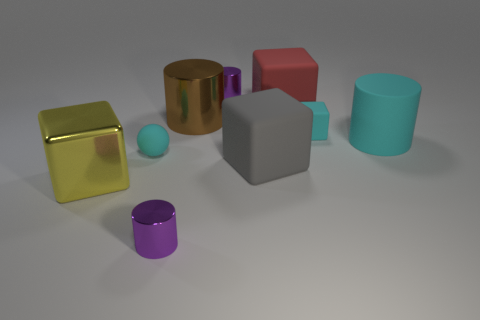Is the number of tiny cylinders in front of the brown cylinder the same as the number of gray matte cubes to the left of the yellow thing?
Keep it short and to the point. No. What number of tiny cylinders are there?
Offer a terse response. 2. Are there more cyan matte balls that are behind the matte ball than large cubes?
Ensure brevity in your answer.  No. What material is the small purple thing that is behind the large red block?
Make the answer very short. Metal. What is the color of the other large rubber object that is the same shape as the large red object?
Offer a very short reply. Gray. How many blocks have the same color as the small matte sphere?
Provide a succinct answer. 1. There is a purple cylinder in front of the cyan sphere; is its size the same as the cyan matte object on the right side of the cyan rubber cube?
Offer a very short reply. No. There is a yellow shiny object; does it have the same size as the shiny cylinder that is behind the big brown shiny thing?
Make the answer very short. No. The brown metal cylinder is what size?
Your response must be concise. Large. What color is the other big cube that is made of the same material as the big gray block?
Provide a short and direct response. Red. 